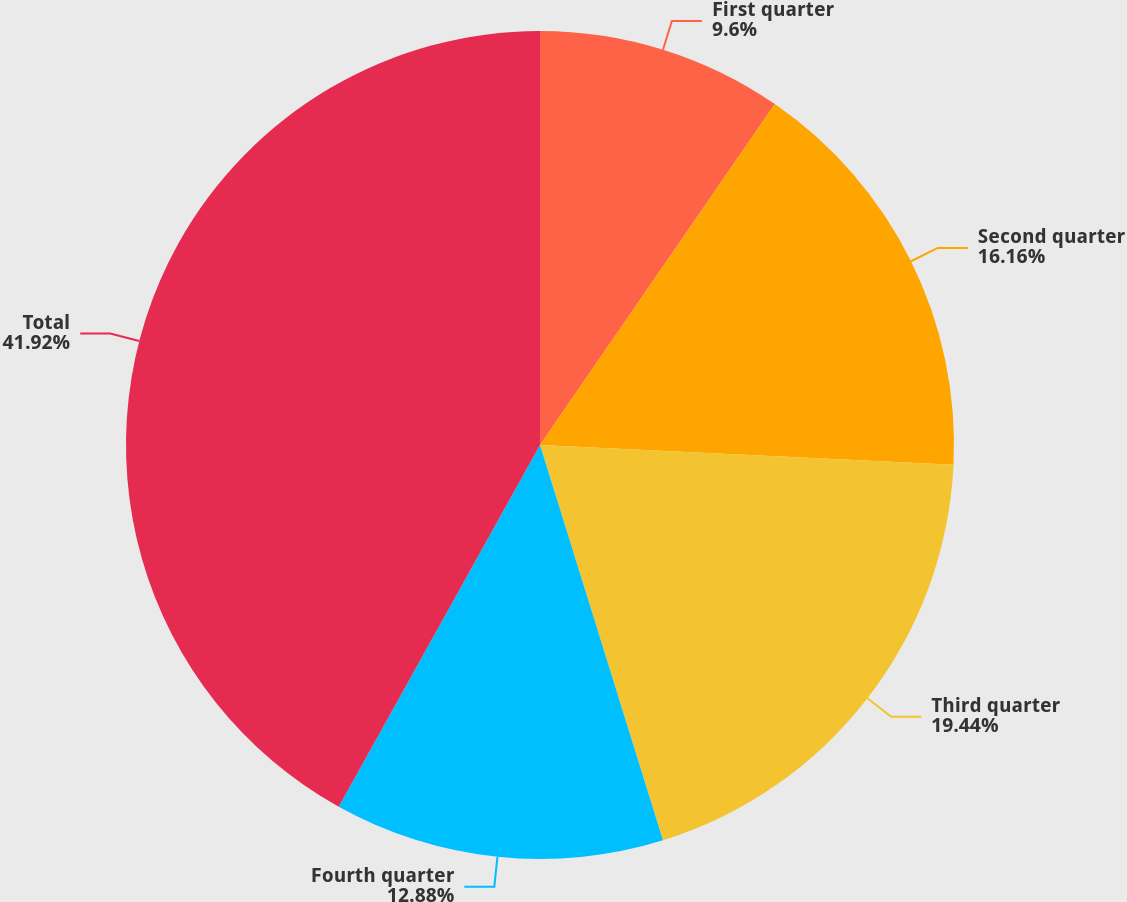<chart> <loc_0><loc_0><loc_500><loc_500><pie_chart><fcel>First quarter<fcel>Second quarter<fcel>Third quarter<fcel>Fourth quarter<fcel>Total<nl><fcel>9.6%<fcel>16.16%<fcel>19.44%<fcel>12.88%<fcel>41.92%<nl></chart> 